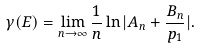<formula> <loc_0><loc_0><loc_500><loc_500>\gamma ( E ) = \lim _ { n \to \infty } \frac { 1 } { n } \ln | A _ { n } + \frac { B _ { n } } { p _ { 1 } } | .</formula> 